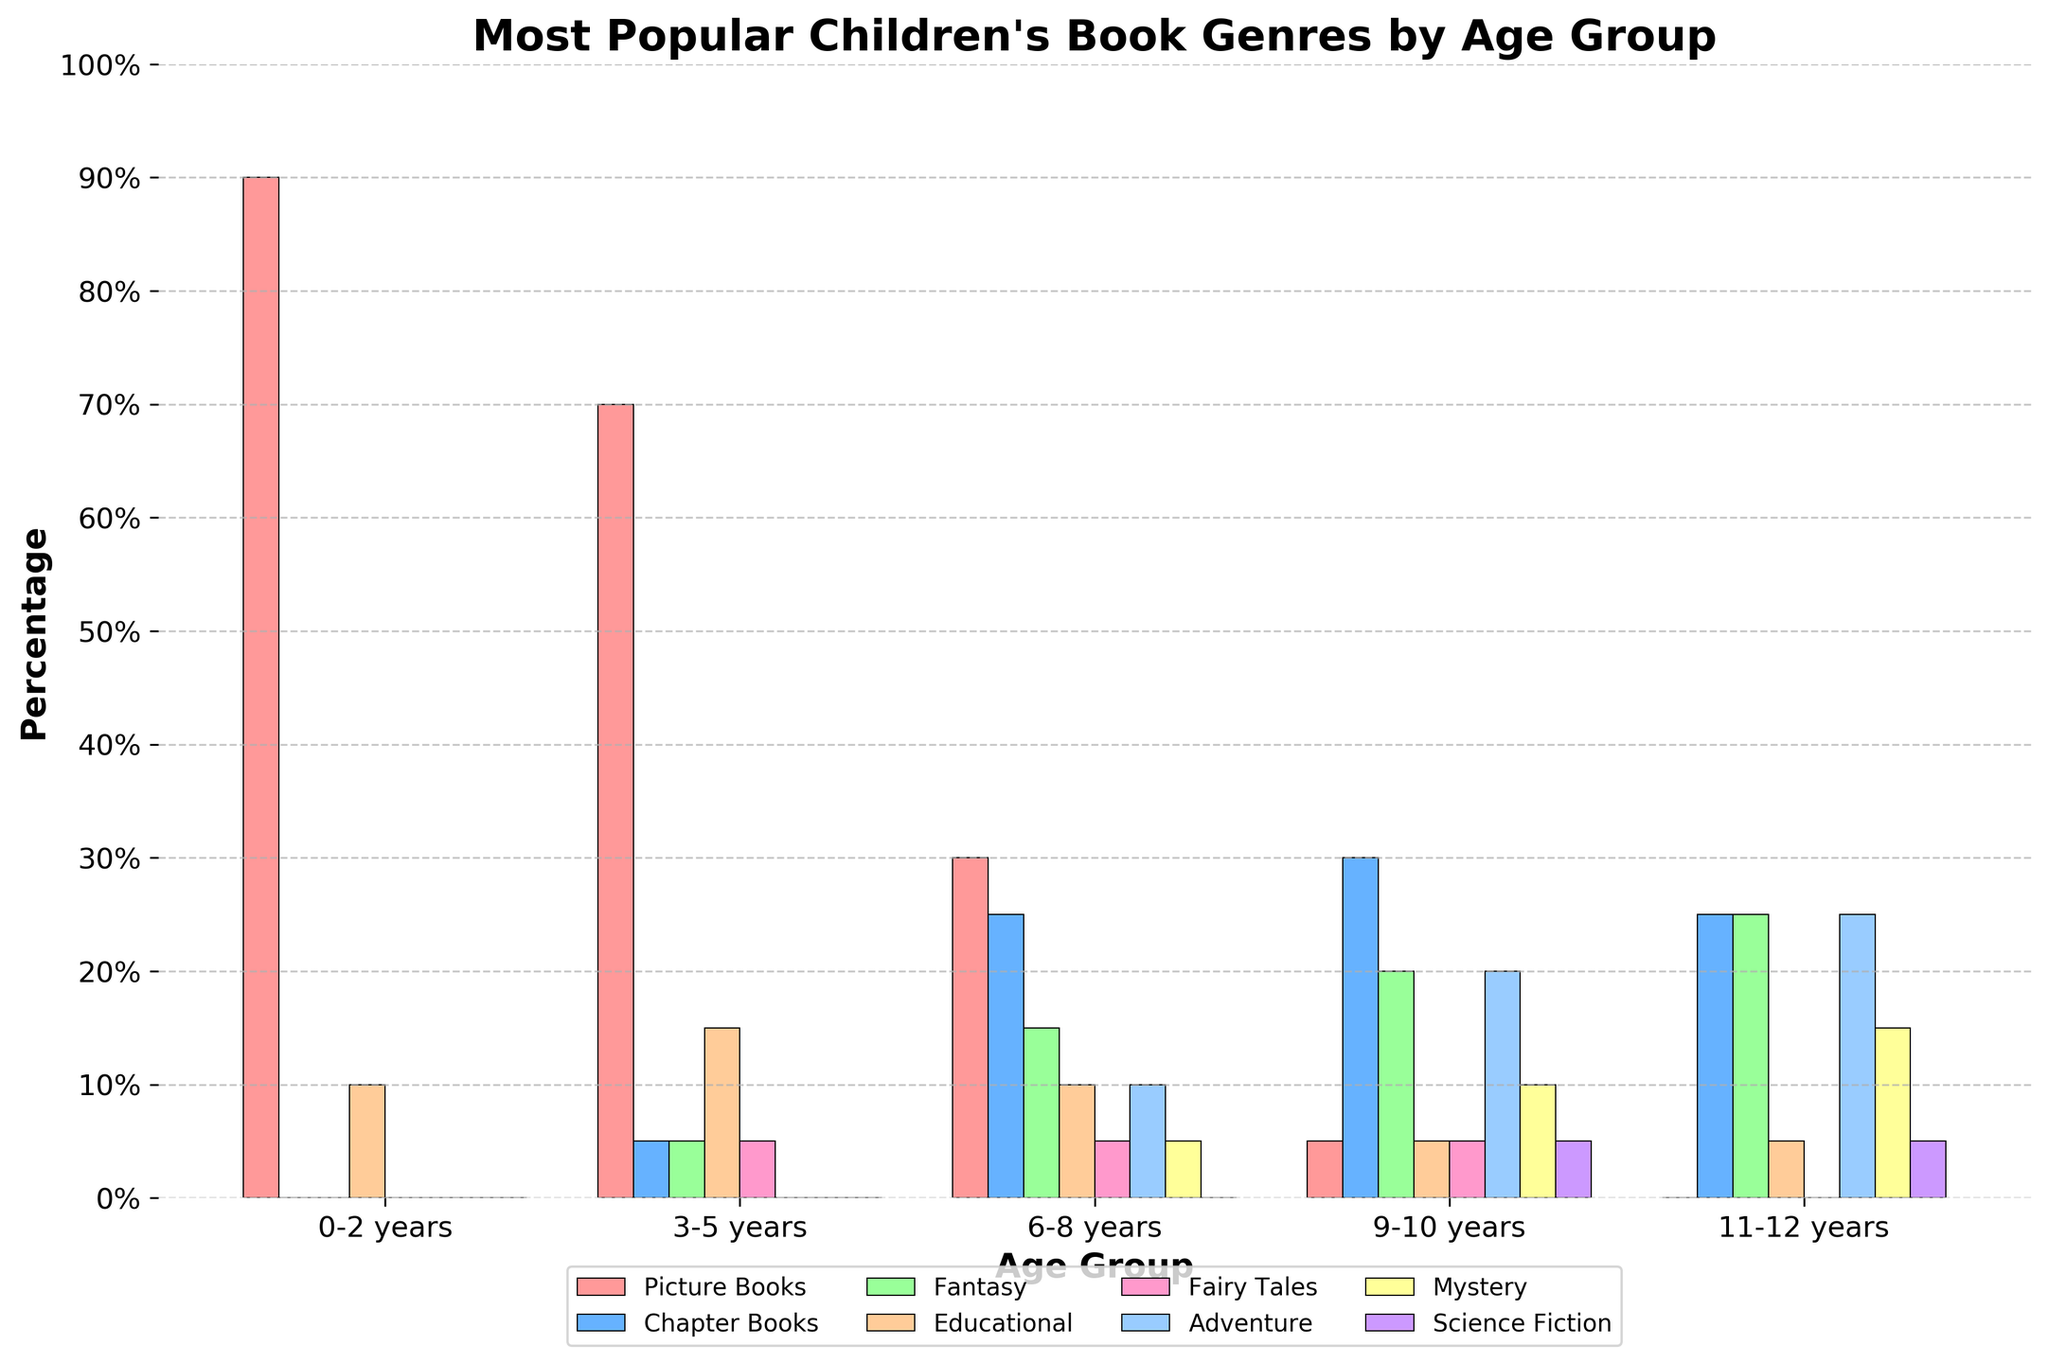which age group has the highest percentage for picture books? The bar for Picture Books is the tallest for the 0-2 years age group, indicating the highest percentage.
Answer: 0-2 years how do the percentages of picture books and educational books compare for the 3-5 years age group? In the 3-5 years age group, Picture Books have a percentage of 70, while Educational Books have a percentage of 15. Picture Books are significantly higher in percentage than Educational Books.
Answer: Picture Books are higher which genre has seen a consistent increase from 0-2 years to 11-12 years? Only Chapter Books show a consistent increase when observing the bar heights from 0-2 years to 11-12 years age groups.
Answer: Chapter Books what is the total percentage of adventure books for all age groups combined? Summing the percentages of Adventure books across all age groups: 0 + 0 + 10 + 20 + 25 = 55%
Answer: 55% which two genres have the same percentage for the 9-10 years age group? Observing the bars for the 9-10 years age group, Fairy Tales and Educational both have a height corresponding to 5%.
Answer: Fairy Tales and Educational which age group shows the largest diversity in genre preferences? The 9-10 and 11-12 years age groups have non-zero percentages for all genres, indicating the largest diversity in their preferences.
Answer: 9-10 years and 11-12 years what is the difference in percentage between fantasy books for the 6-8 years and 11-12 years age groups? Fantasy books are at 15% for 6-8 years and 25% for 11-12 years. The difference is calculated as 25 - 15 = 10%.
Answer: 10% how do the percentages of picture books change from 0-2 years to 11-12 years? Picture Books start at 90% for 0-2 years and gradually decrease with each age group until reaching 0% for 11-12 years.
Answer: Decrease to 0% which genre is least popular for the 3-5 years age group? The bars for the 3-5 years age group show a 0% value for both Adventure and Science Fiction, making them the least popular genres for this age group.
Answer: Adventure and Science Fiction which age group has an equal percentage for mystery and science fiction genres? The bar heights in the 9-10 years age group for both Mystery and Science Fiction show 5%.
Answer: 9-10 years 